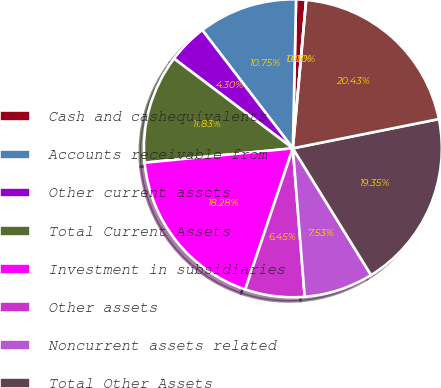Convert chart to OTSL. <chart><loc_0><loc_0><loc_500><loc_500><pie_chart><fcel>Cash and cashequivalents<fcel>Accounts receivable from<fcel>Other current assets<fcel>Total Current Assets<fcel>Investment in subsidiaries<fcel>Other assets<fcel>Noncurrent assets related<fcel>Total Other Assets<fcel>Total Assets<fcel>Current liabilities related to<nl><fcel>1.08%<fcel>10.75%<fcel>4.3%<fcel>11.83%<fcel>18.28%<fcel>6.45%<fcel>7.53%<fcel>19.35%<fcel>20.43%<fcel>0.0%<nl></chart> 